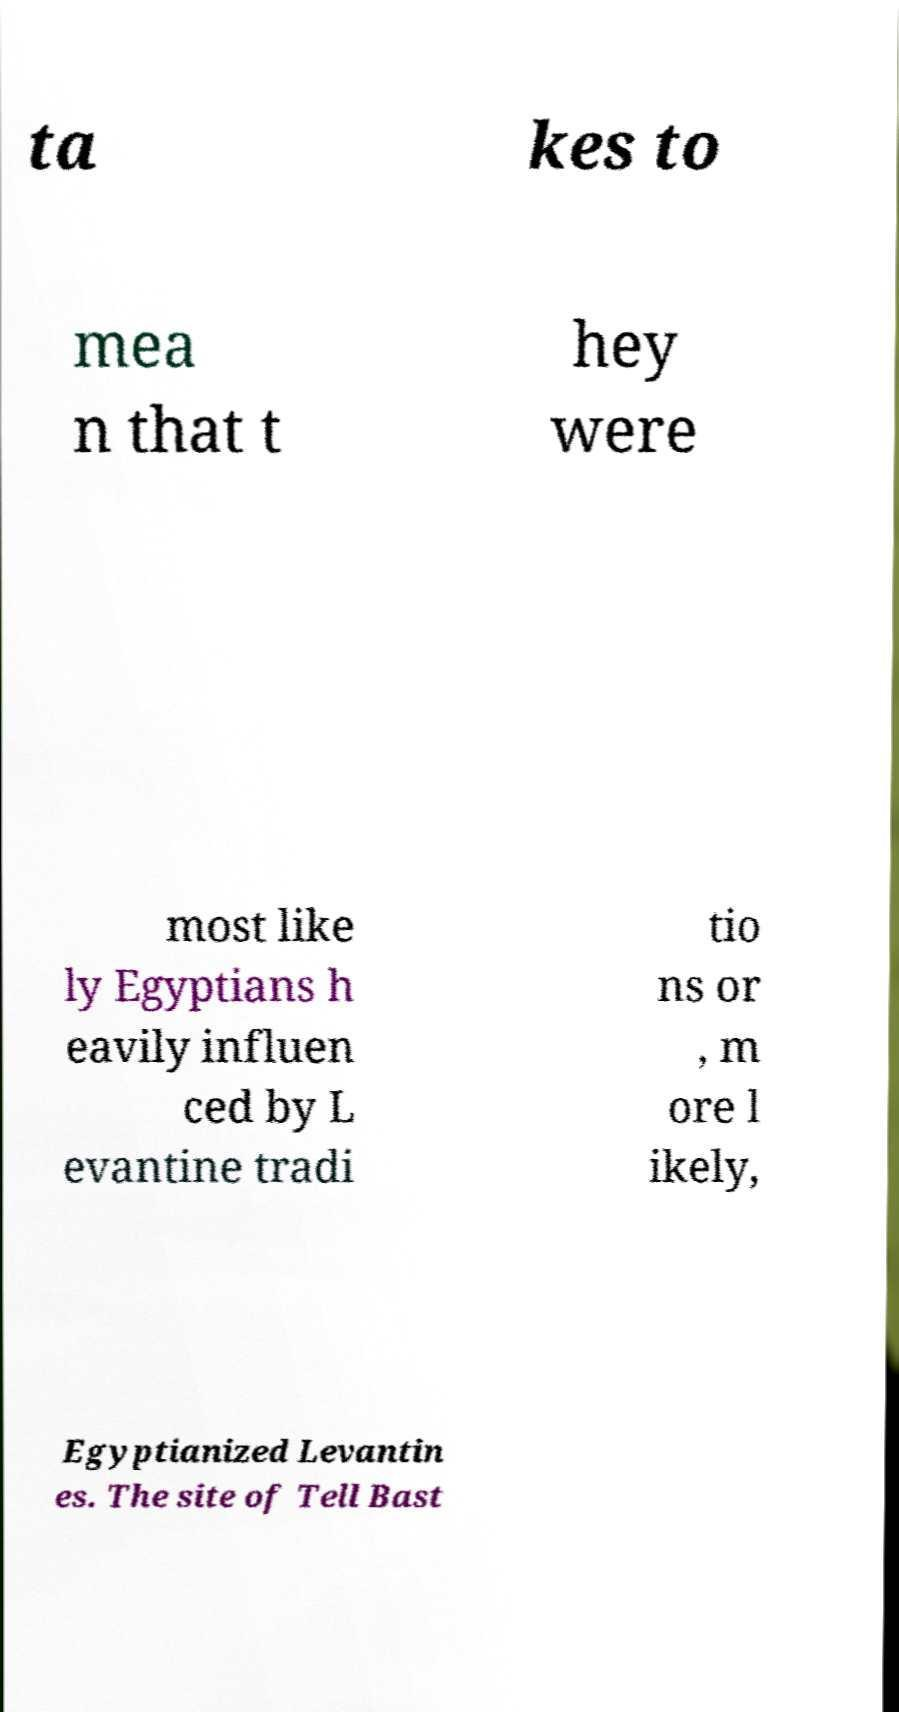Please identify and transcribe the text found in this image. ta kes to mea n that t hey were most like ly Egyptians h eavily influen ced by L evantine tradi tio ns or , m ore l ikely, Egyptianized Levantin es. The site of Tell Bast 